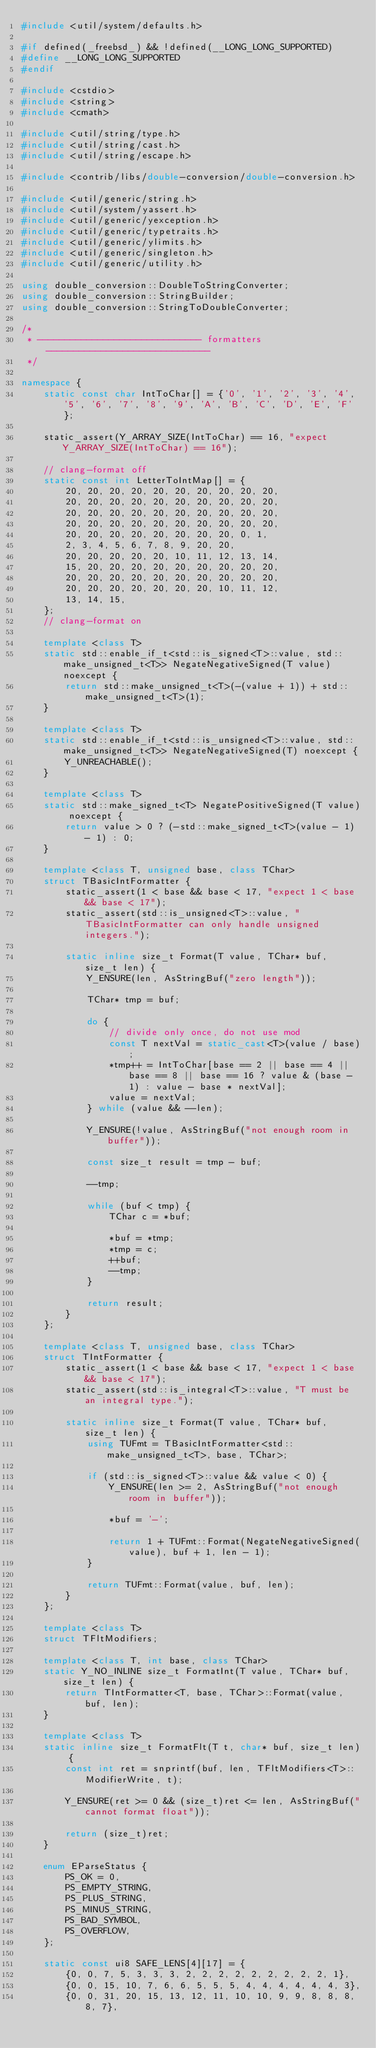Convert code to text. <code><loc_0><loc_0><loc_500><loc_500><_C++_>#include <util/system/defaults.h>

#if defined(_freebsd_) && !defined(__LONG_LONG_SUPPORTED)
#define __LONG_LONG_SUPPORTED
#endif

#include <cstdio>
#include <string>
#include <cmath>

#include <util/string/type.h>
#include <util/string/cast.h>
#include <util/string/escape.h>

#include <contrib/libs/double-conversion/double-conversion.h>

#include <util/generic/string.h>
#include <util/system/yassert.h>
#include <util/generic/yexception.h>
#include <util/generic/typetraits.h>
#include <util/generic/ylimits.h>
#include <util/generic/singleton.h>
#include <util/generic/utility.h>

using double_conversion::DoubleToStringConverter;
using double_conversion::StringBuilder;
using double_conversion::StringToDoubleConverter;

/*
 * ------------------------------ formatters ------------------------------
 */

namespace {
    static const char IntToChar[] = {'0', '1', '2', '3', '4', '5', '6', '7', '8', '9', 'A', 'B', 'C', 'D', 'E', 'F'};

    static_assert(Y_ARRAY_SIZE(IntToChar) == 16, "expect Y_ARRAY_SIZE(IntToChar) == 16");

    // clang-format off
    static const int LetterToIntMap[] = {
        20, 20, 20, 20, 20, 20, 20, 20, 20, 20,
        20, 20, 20, 20, 20, 20, 20, 20, 20, 20,
        20, 20, 20, 20, 20, 20, 20, 20, 20, 20,
        20, 20, 20, 20, 20, 20, 20, 20, 20, 20,
        20, 20, 20, 20, 20, 20, 20, 20, 0, 1,
        2, 3, 4, 5, 6, 7, 8, 9, 20, 20,
        20, 20, 20, 20, 20, 10, 11, 12, 13, 14,
        15, 20, 20, 20, 20, 20, 20, 20, 20, 20,
        20, 20, 20, 20, 20, 20, 20, 20, 20, 20,
        20, 20, 20, 20, 20, 20, 20, 10, 11, 12,
        13, 14, 15,
    };
    // clang-format on

    template <class T>
    static std::enable_if_t<std::is_signed<T>::value, std::make_unsigned_t<T>> NegateNegativeSigned(T value) noexcept {
        return std::make_unsigned_t<T>(-(value + 1)) + std::make_unsigned_t<T>(1);
    }

    template <class T>
    static std::enable_if_t<std::is_unsigned<T>::value, std::make_unsigned_t<T>> NegateNegativeSigned(T) noexcept {
        Y_UNREACHABLE();
    }

    template <class T>
    static std::make_signed_t<T> NegatePositiveSigned(T value) noexcept {
        return value > 0 ? (-std::make_signed_t<T>(value - 1) - 1) : 0;
    }

    template <class T, unsigned base, class TChar>
    struct TBasicIntFormatter {
        static_assert(1 < base && base < 17, "expect 1 < base && base < 17");
        static_assert(std::is_unsigned<T>::value, "TBasicIntFormatter can only handle unsigned integers.");

        static inline size_t Format(T value, TChar* buf, size_t len) {
            Y_ENSURE(len, AsStringBuf("zero length"));

            TChar* tmp = buf;

            do {
                // divide only once, do not use mod
                const T nextVal = static_cast<T>(value / base);
                *tmp++ = IntToChar[base == 2 || base == 4 || base == 8 || base == 16 ? value & (base - 1) : value - base * nextVal];
                value = nextVal;
            } while (value && --len);

            Y_ENSURE(!value, AsStringBuf("not enough room in buffer"));

            const size_t result = tmp - buf;

            --tmp;

            while (buf < tmp) {
                TChar c = *buf;

                *buf = *tmp;
                *tmp = c;
                ++buf;
                --tmp;
            }

            return result;
        }
    };

    template <class T, unsigned base, class TChar>
    struct TIntFormatter {
        static_assert(1 < base && base < 17, "expect 1 < base && base < 17");
        static_assert(std::is_integral<T>::value, "T must be an integral type.");

        static inline size_t Format(T value, TChar* buf, size_t len) {
            using TUFmt = TBasicIntFormatter<std::make_unsigned_t<T>, base, TChar>;

            if (std::is_signed<T>::value && value < 0) {
                Y_ENSURE(len >= 2, AsStringBuf("not enough room in buffer"));

                *buf = '-';

                return 1 + TUFmt::Format(NegateNegativeSigned(value), buf + 1, len - 1);
            }

            return TUFmt::Format(value, buf, len);
        }
    };

    template <class T>
    struct TFltModifiers;

    template <class T, int base, class TChar>
    static Y_NO_INLINE size_t FormatInt(T value, TChar* buf, size_t len) {
        return TIntFormatter<T, base, TChar>::Format(value, buf, len);
    }

    template <class T>
    static inline size_t FormatFlt(T t, char* buf, size_t len) {
        const int ret = snprintf(buf, len, TFltModifiers<T>::ModifierWrite, t);

        Y_ENSURE(ret >= 0 && (size_t)ret <= len, AsStringBuf("cannot format float"));

        return (size_t)ret;
    }

    enum EParseStatus {
        PS_OK = 0,
        PS_EMPTY_STRING,
        PS_PLUS_STRING,
        PS_MINUS_STRING,
        PS_BAD_SYMBOL,
        PS_OVERFLOW,
    };

    static const ui8 SAFE_LENS[4][17] = {
        {0, 0, 7, 5, 3, 3, 3, 2, 2, 2, 2, 2, 2, 2, 2, 2, 1},
        {0, 0, 15, 10, 7, 6, 6, 5, 5, 5, 4, 4, 4, 4, 4, 4, 3},
        {0, 0, 31, 20, 15, 13, 12, 11, 10, 10, 9, 9, 8, 8, 8, 8, 7},</code> 